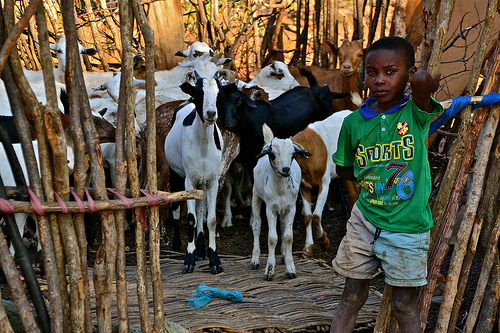<image>
Is there a goat to the right of the boy? Yes. From this viewpoint, the goat is positioned to the right side relative to the boy. 